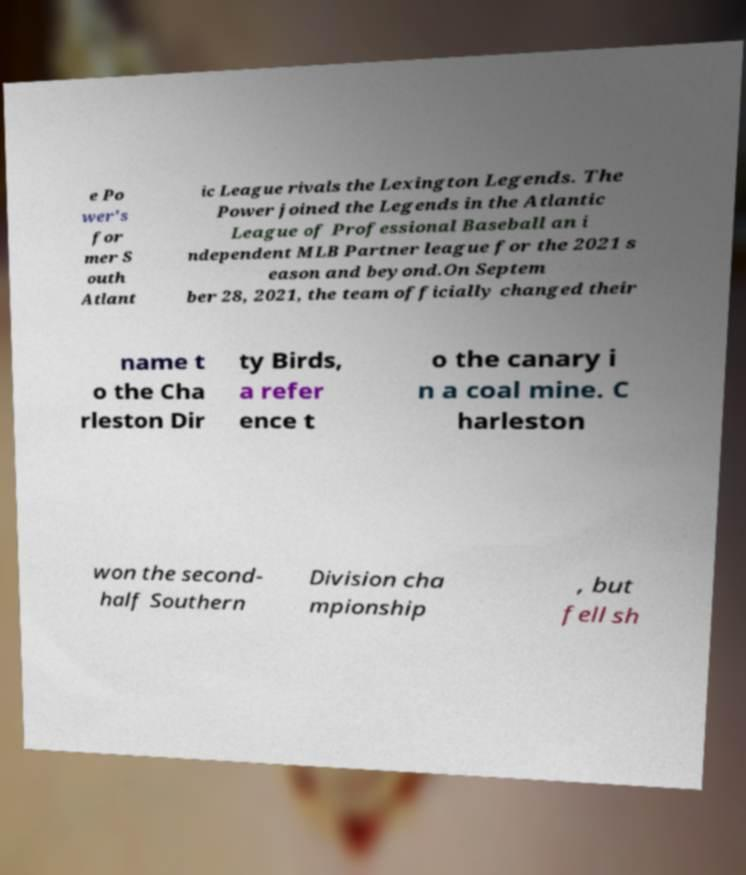For documentation purposes, I need the text within this image transcribed. Could you provide that? e Po wer's for mer S outh Atlant ic League rivals the Lexington Legends. The Power joined the Legends in the Atlantic League of Professional Baseball an i ndependent MLB Partner league for the 2021 s eason and beyond.On Septem ber 28, 2021, the team officially changed their name t o the Cha rleston Dir ty Birds, a refer ence t o the canary i n a coal mine. C harleston won the second- half Southern Division cha mpionship , but fell sh 